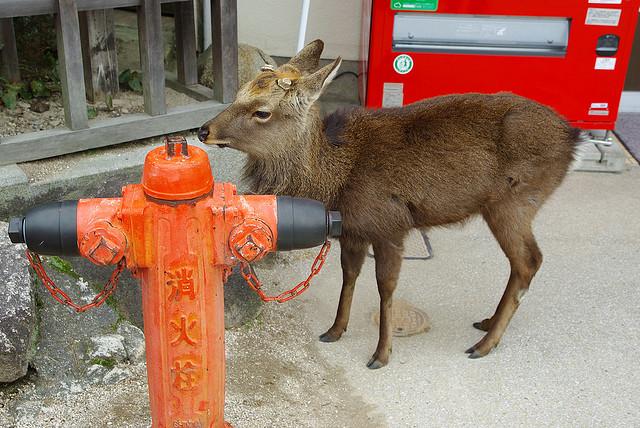IS this a dog?
Give a very brief answer. No. What is the dog standing on?
Quick response, please. Concrete. Is he tied to a fire hydrant?
Write a very short answer. No. 